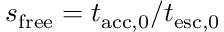<formula> <loc_0><loc_0><loc_500><loc_500>s _ { f r e e } = t _ { a c c , 0 } / t _ { e s c , 0 }</formula> 